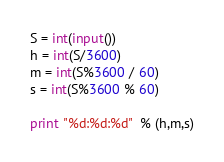Convert code to text. <code><loc_0><loc_0><loc_500><loc_500><_Python_>S = int(input())
h = int(S/3600)
m = int(S%3600 / 60)
s = int(S%3600 % 60) 

print "%d:%d:%d"  % (h,m,s)</code> 